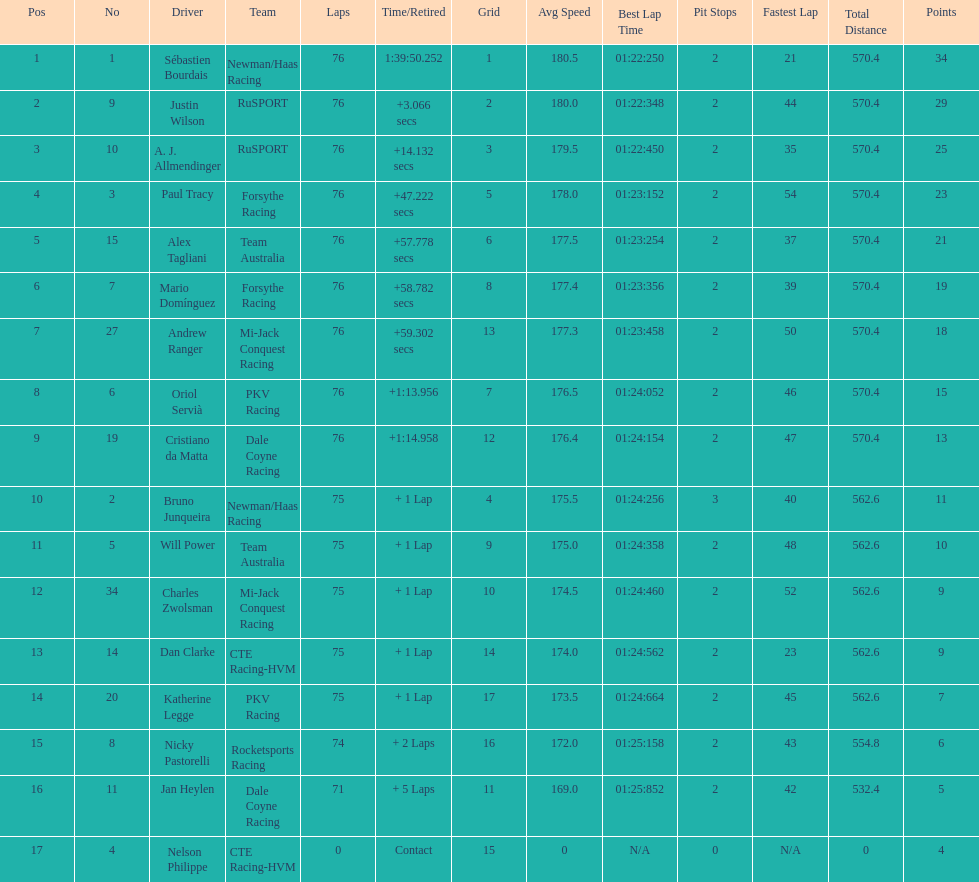Which driver earned the least amount of points. Nelson Philippe. 